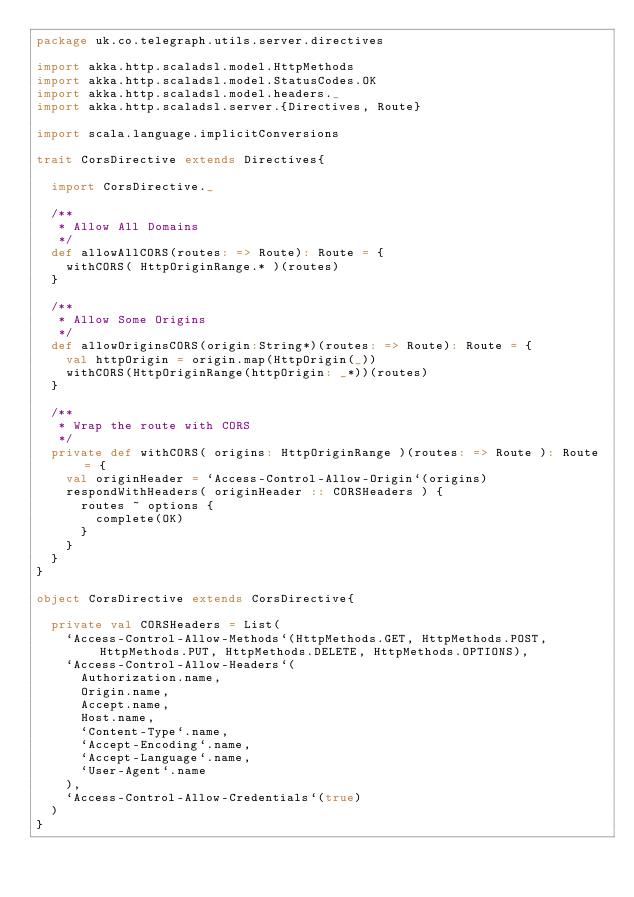Convert code to text. <code><loc_0><loc_0><loc_500><loc_500><_Scala_>package uk.co.telegraph.utils.server.directives

import akka.http.scaladsl.model.HttpMethods
import akka.http.scaladsl.model.StatusCodes.OK
import akka.http.scaladsl.model.headers._
import akka.http.scaladsl.server.{Directives, Route}

import scala.language.implicitConversions

trait CorsDirective extends Directives{

  import CorsDirective._

  /**
   * Allow All Domains
   */
  def allowAllCORS(routes: => Route): Route = {
    withCORS( HttpOriginRange.* )(routes)
  }

  /**
   * Allow Some Origins
   */
  def allowOriginsCORS(origin:String*)(routes: => Route): Route = {
    val httpOrigin = origin.map(HttpOrigin(_))
    withCORS(HttpOriginRange(httpOrigin: _*))(routes)
  }

  /**
   * Wrap the route with CORS
   */
  private def withCORS( origins: HttpOriginRange )(routes: => Route ): Route = {
    val originHeader = `Access-Control-Allow-Origin`(origins)
    respondWithHeaders( originHeader :: CORSHeaders ) {
      routes ~ options {
        complete(OK)
      }
    }
  }
}

object CorsDirective extends CorsDirective{

  private val CORSHeaders = List(
    `Access-Control-Allow-Methods`(HttpMethods.GET, HttpMethods.POST, HttpMethods.PUT, HttpMethods.DELETE, HttpMethods.OPTIONS),
    `Access-Control-Allow-Headers`(
      Authorization.name,
      Origin.name,
      Accept.name,
      Host.name,
      `Content-Type`.name,
      `Accept-Encoding`.name,
      `Accept-Language`.name,
      `User-Agent`.name
    ),
    `Access-Control-Allow-Credentials`(true)
  )
}</code> 